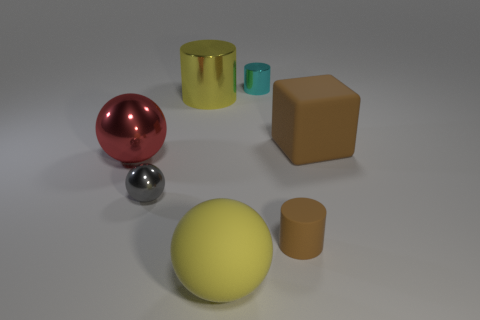Subtract all large balls. How many balls are left? 1 Add 2 big brown cubes. How many objects exist? 9 Subtract all blocks. How many objects are left? 6 Subtract 0 red cylinders. How many objects are left? 7 Subtract all cylinders. Subtract all big spheres. How many objects are left? 2 Add 4 small cyan metal cylinders. How many small cyan metal cylinders are left? 5 Add 3 tiny brown cylinders. How many tiny brown cylinders exist? 4 